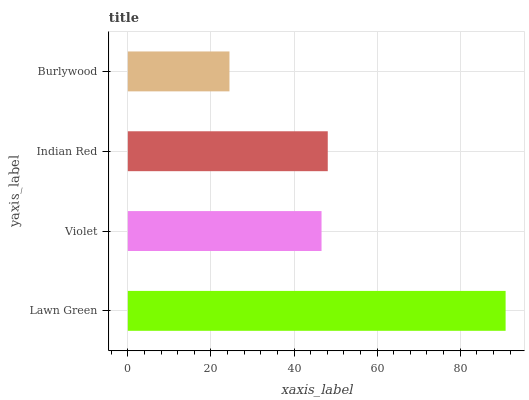Is Burlywood the minimum?
Answer yes or no. Yes. Is Lawn Green the maximum?
Answer yes or no. Yes. Is Violet the minimum?
Answer yes or no. No. Is Violet the maximum?
Answer yes or no. No. Is Lawn Green greater than Violet?
Answer yes or no. Yes. Is Violet less than Lawn Green?
Answer yes or no. Yes. Is Violet greater than Lawn Green?
Answer yes or no. No. Is Lawn Green less than Violet?
Answer yes or no. No. Is Indian Red the high median?
Answer yes or no. Yes. Is Violet the low median?
Answer yes or no. Yes. Is Lawn Green the high median?
Answer yes or no. No. Is Lawn Green the low median?
Answer yes or no. No. 